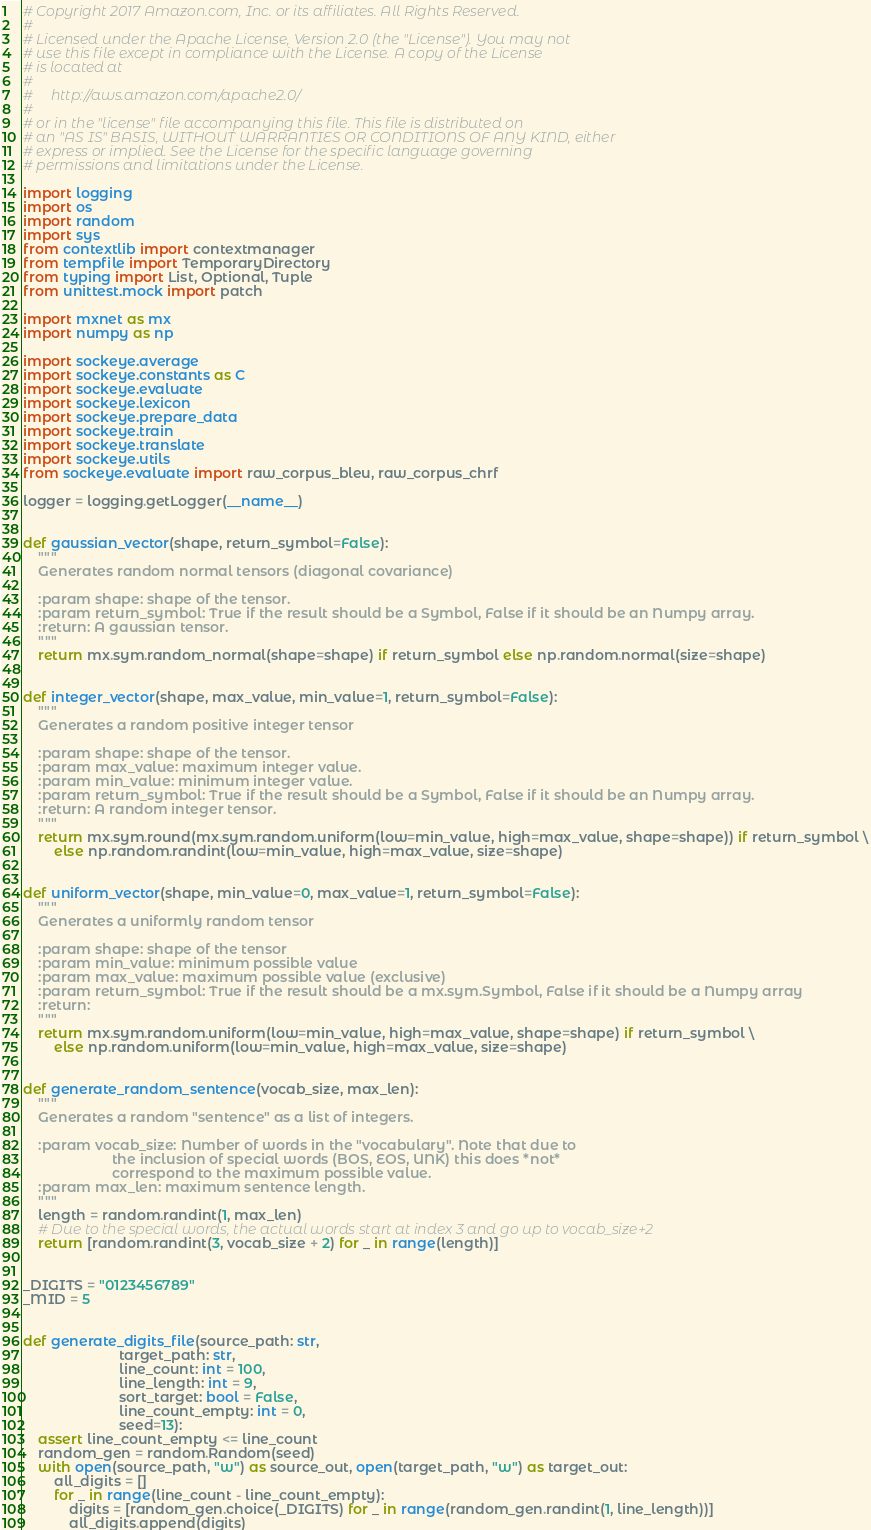<code> <loc_0><loc_0><loc_500><loc_500><_Python_># Copyright 2017 Amazon.com, Inc. or its affiliates. All Rights Reserved.
#
# Licensed under the Apache License, Version 2.0 (the "License"). You may not
# use this file except in compliance with the License. A copy of the License
# is located at
#
#     http://aws.amazon.com/apache2.0/
#
# or in the "license" file accompanying this file. This file is distributed on
# an "AS IS" BASIS, WITHOUT WARRANTIES OR CONDITIONS OF ANY KIND, either
# express or implied. See the License for the specific language governing
# permissions and limitations under the License.

import logging
import os
import random
import sys
from contextlib import contextmanager
from tempfile import TemporaryDirectory
from typing import List, Optional, Tuple
from unittest.mock import patch

import mxnet as mx
import numpy as np

import sockeye.average
import sockeye.constants as C
import sockeye.evaluate
import sockeye.lexicon
import sockeye.prepare_data
import sockeye.train
import sockeye.translate
import sockeye.utils
from sockeye.evaluate import raw_corpus_bleu, raw_corpus_chrf

logger = logging.getLogger(__name__)


def gaussian_vector(shape, return_symbol=False):
    """
    Generates random normal tensors (diagonal covariance)

    :param shape: shape of the tensor.
    :param return_symbol: True if the result should be a Symbol, False if it should be an Numpy array.
    :return: A gaussian tensor.
    """
    return mx.sym.random_normal(shape=shape) if return_symbol else np.random.normal(size=shape)


def integer_vector(shape, max_value, min_value=1, return_symbol=False):
    """
    Generates a random positive integer tensor

    :param shape: shape of the tensor.
    :param max_value: maximum integer value.
    :param min_value: minimum integer value.
    :param return_symbol: True if the result should be a Symbol, False if it should be an Numpy array.
    :return: A random integer tensor.
    """
    return mx.sym.round(mx.sym.random.uniform(low=min_value, high=max_value, shape=shape)) if return_symbol \
        else np.random.randint(low=min_value, high=max_value, size=shape)


def uniform_vector(shape, min_value=0, max_value=1, return_symbol=False):
    """
    Generates a uniformly random tensor

    :param shape: shape of the tensor
    :param min_value: minimum possible value
    :param max_value: maximum possible value (exclusive)
    :param return_symbol: True if the result should be a mx.sym.Symbol, False if it should be a Numpy array
    :return:
    """
    return mx.sym.random.uniform(low=min_value, high=max_value, shape=shape) if return_symbol \
        else np.random.uniform(low=min_value, high=max_value, size=shape)


def generate_random_sentence(vocab_size, max_len):
    """
    Generates a random "sentence" as a list of integers.

    :param vocab_size: Number of words in the "vocabulary". Note that due to
                       the inclusion of special words (BOS, EOS, UNK) this does *not*
                       correspond to the maximum possible value.
    :param max_len: maximum sentence length.
    """
    length = random.randint(1, max_len)
    # Due to the special words, the actual words start at index 3 and go up to vocab_size+2
    return [random.randint(3, vocab_size + 2) for _ in range(length)]


_DIGITS = "0123456789"
_MID = 5


def generate_digits_file(source_path: str,
                         target_path: str,
                         line_count: int = 100,
                         line_length: int = 9,
                         sort_target: bool = False,
                         line_count_empty: int = 0,
                         seed=13):
    assert line_count_empty <= line_count
    random_gen = random.Random(seed)
    with open(source_path, "w") as source_out, open(target_path, "w") as target_out:
        all_digits = []
        for _ in range(line_count - line_count_empty):
            digits = [random_gen.choice(_DIGITS) for _ in range(random_gen.randint(1, line_length))]
            all_digits.append(digits)</code> 